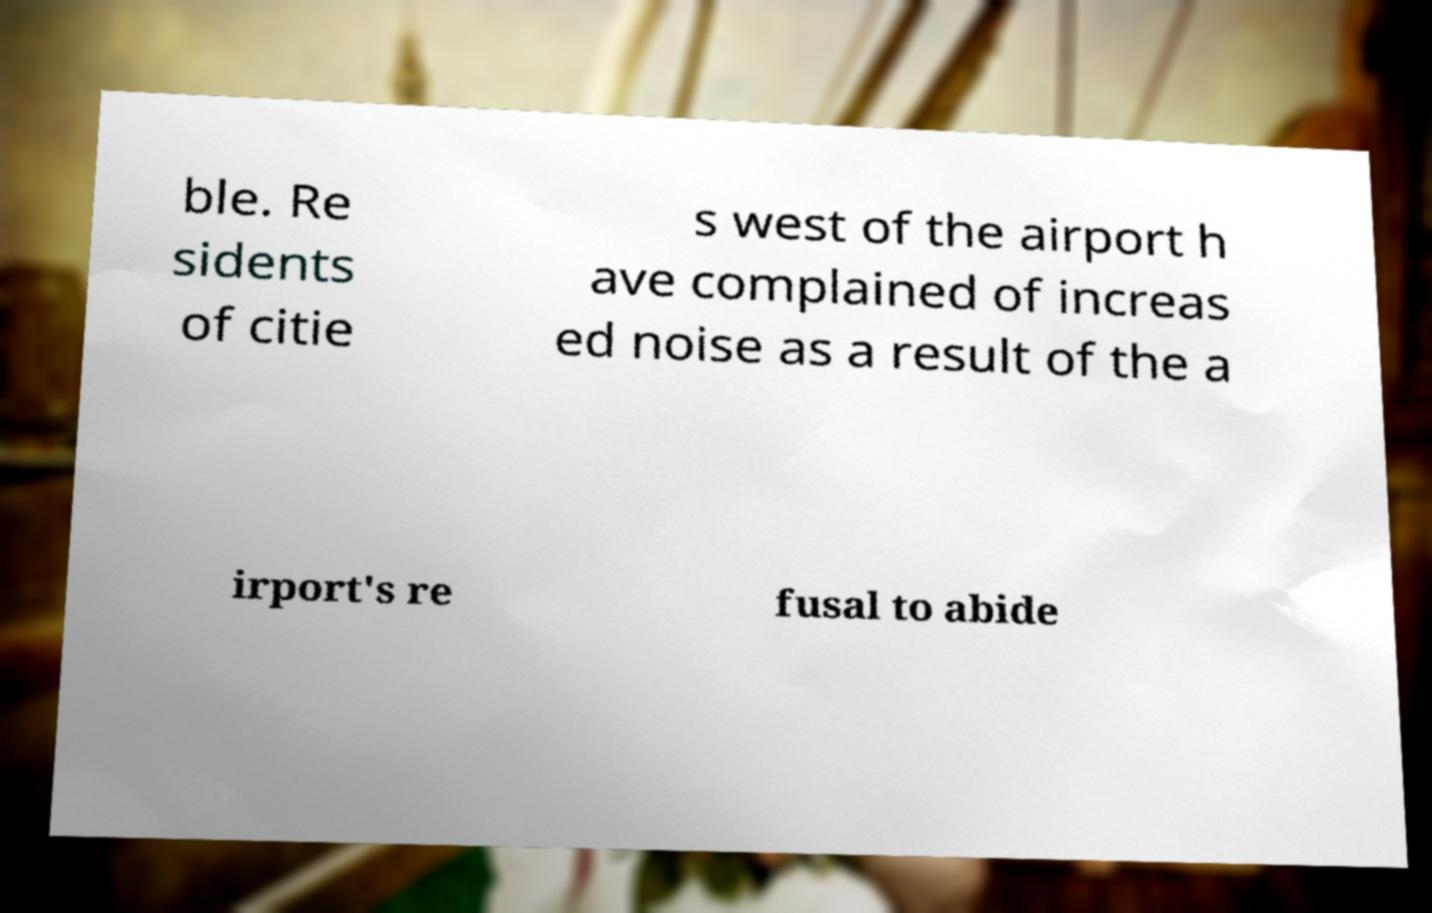Could you assist in decoding the text presented in this image and type it out clearly? ble. Re sidents of citie s west of the airport h ave complained of increas ed noise as a result of the a irport's re fusal to abide 